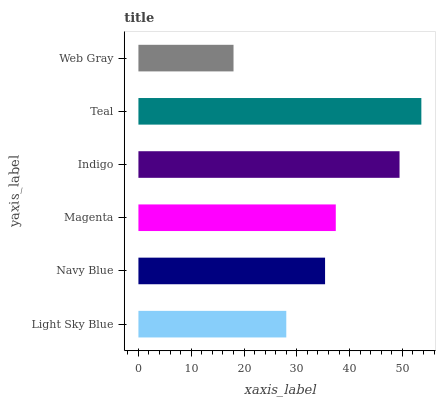Is Web Gray the minimum?
Answer yes or no. Yes. Is Teal the maximum?
Answer yes or no. Yes. Is Navy Blue the minimum?
Answer yes or no. No. Is Navy Blue the maximum?
Answer yes or no. No. Is Navy Blue greater than Light Sky Blue?
Answer yes or no. Yes. Is Light Sky Blue less than Navy Blue?
Answer yes or no. Yes. Is Light Sky Blue greater than Navy Blue?
Answer yes or no. No. Is Navy Blue less than Light Sky Blue?
Answer yes or no. No. Is Magenta the high median?
Answer yes or no. Yes. Is Navy Blue the low median?
Answer yes or no. Yes. Is Indigo the high median?
Answer yes or no. No. Is Magenta the low median?
Answer yes or no. No. 